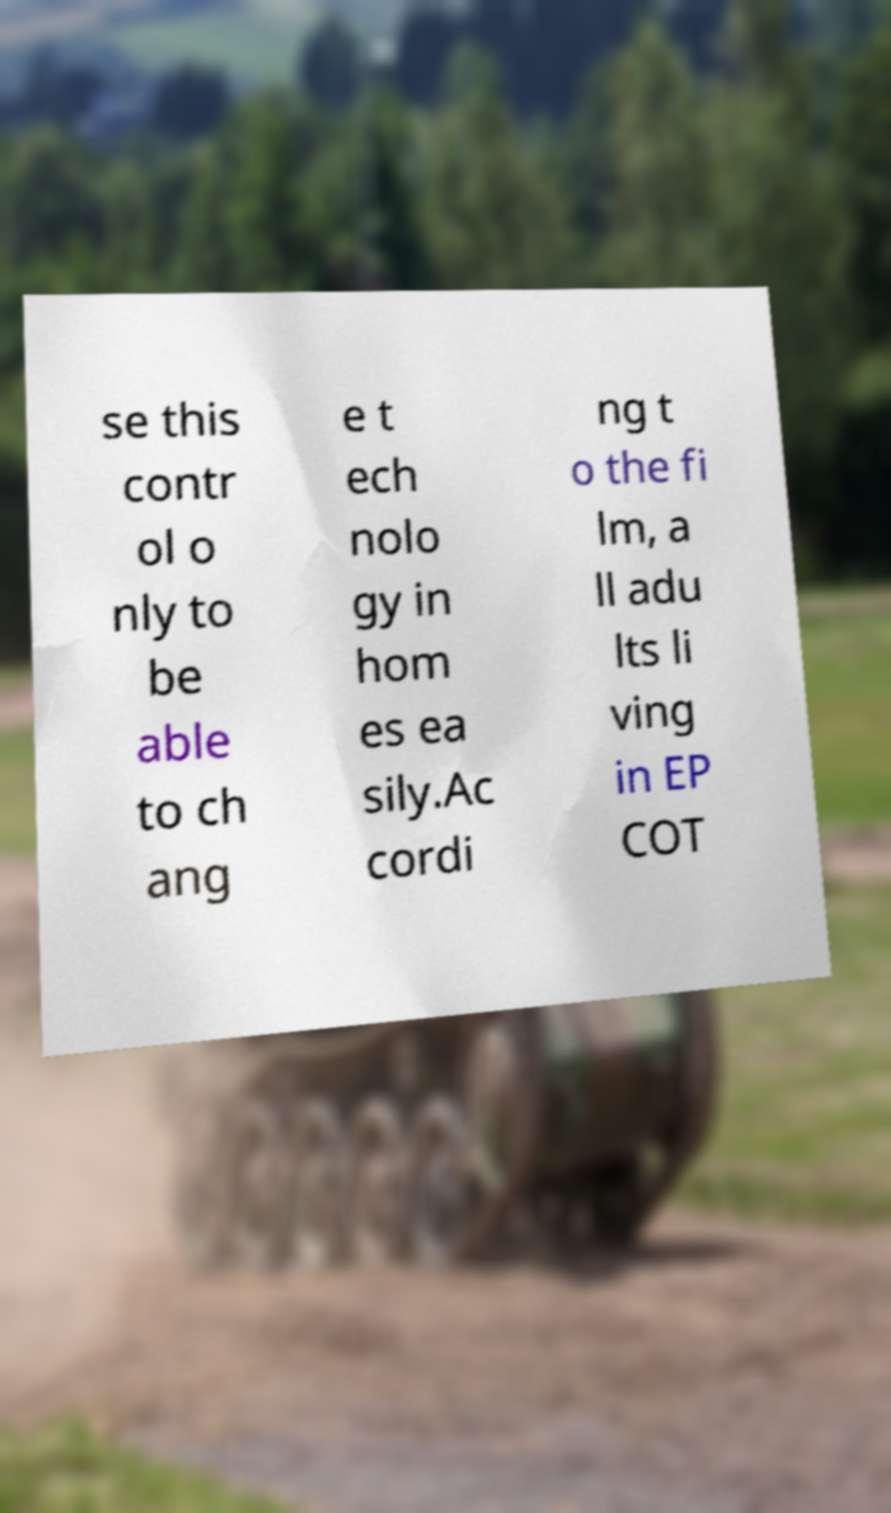Please identify and transcribe the text found in this image. se this contr ol o nly to be able to ch ang e t ech nolo gy in hom es ea sily.Ac cordi ng t o the fi lm, a ll adu lts li ving in EP COT 